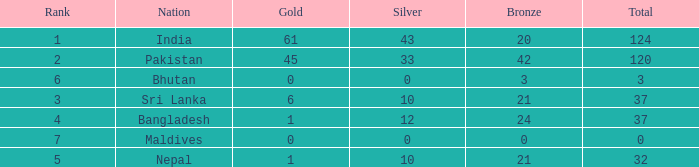Which Gold has a Nation of sri lanka, and a Silver smaller than 10? None. 